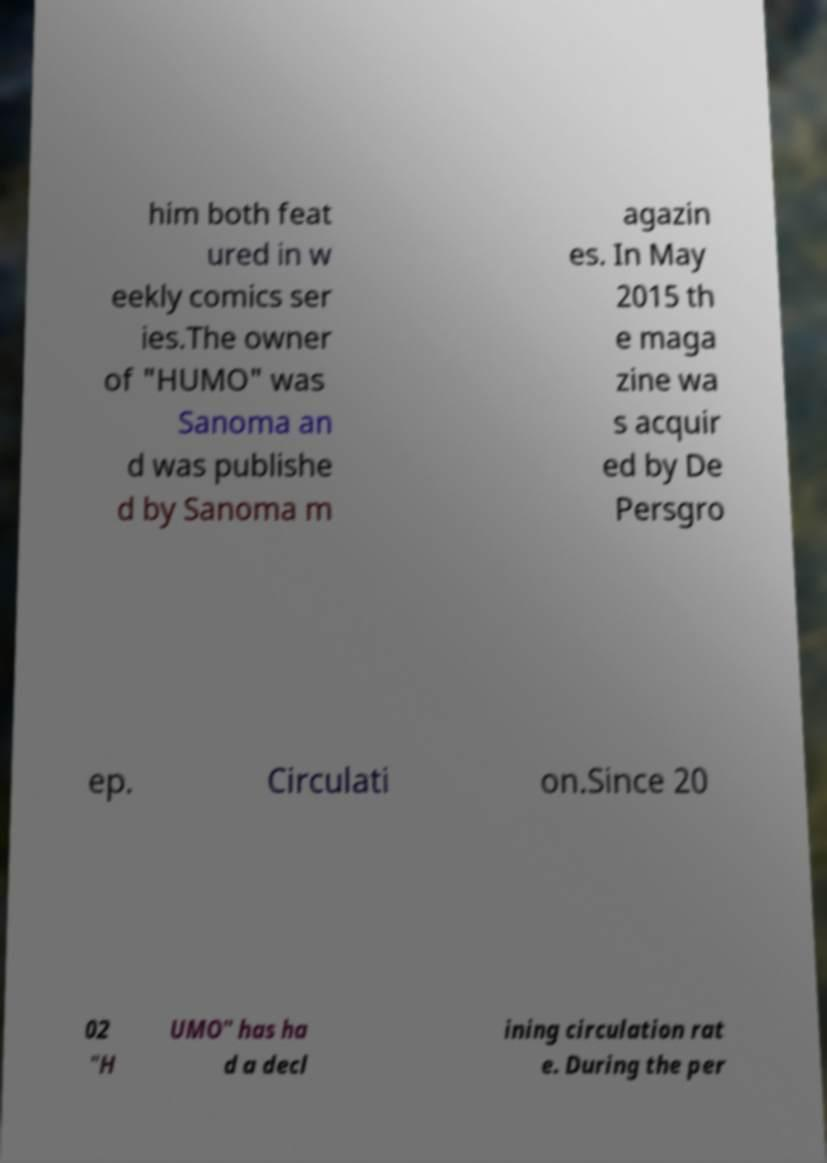For documentation purposes, I need the text within this image transcribed. Could you provide that? him both feat ured in w eekly comics ser ies.The owner of "HUMO" was Sanoma an d was publishe d by Sanoma m agazin es. In May 2015 th e maga zine wa s acquir ed by De Persgro ep. Circulati on.Since 20 02 "H UMO" has ha d a decl ining circulation rat e. During the per 